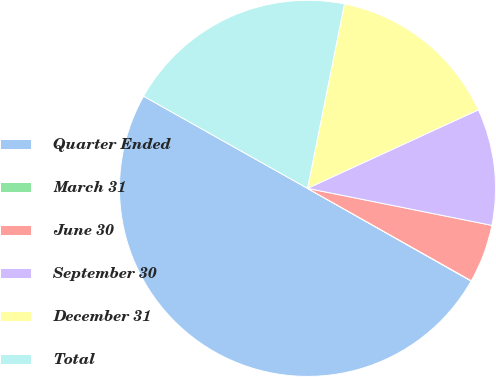Convert chart to OTSL. <chart><loc_0><loc_0><loc_500><loc_500><pie_chart><fcel>Quarter Ended<fcel>March 31<fcel>June 30<fcel>September 30<fcel>December 31<fcel>Total<nl><fcel>49.95%<fcel>0.03%<fcel>5.02%<fcel>10.01%<fcel>15.0%<fcel>19.99%<nl></chart> 